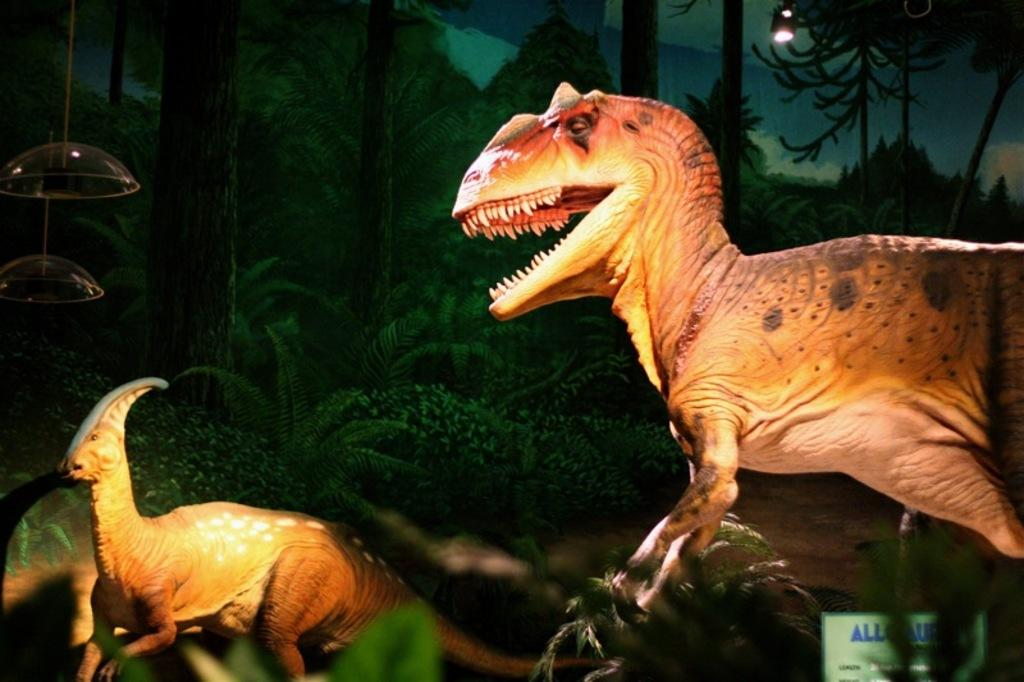What is the main subject in the foreground of the image? There are two dinosaur sculptures in the foreground of the image. What can be seen in the background of the image? In the background of the image, there is a painted cardboard. What type of room is depicted in the image? There is no room depicted in the image; it features two dinosaur sculptures in the foreground and a painted cardboard in the background. How does the painted cardboard affect the dinosaur's throat in the image? The painted cardboard does not affect the dinosaur's throat in the image, as it is a separate element in the background and not connected to the dinosaur sculptures. 